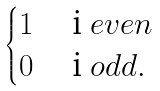Convert formula to latex. <formula><loc_0><loc_0><loc_500><loc_500>\begin{cases} 1 & $ i $ e v e n \\ 0 & $ i $ o d d . \end{cases}</formula> 